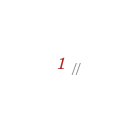<code> <loc_0><loc_0><loc_500><loc_500><_C_>//</code> 